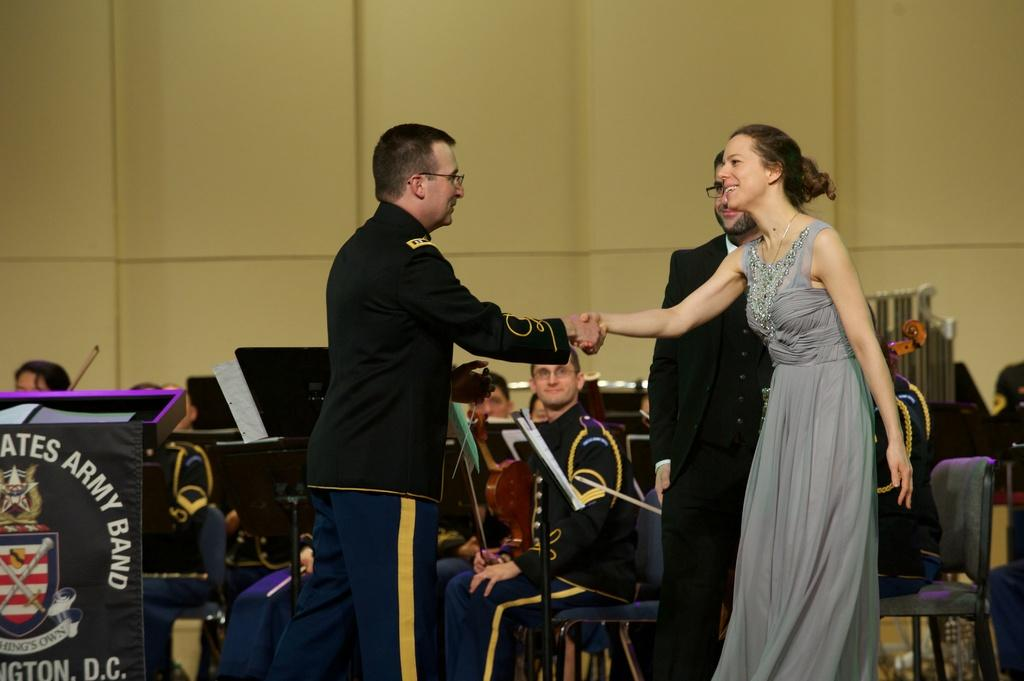What are the two people in the image doing? Two people are shaking hands in the image. What can be seen in the background of the image? There are people sitting on chairs in the background. What objects related to learning or knowledge are visible in the image? There are books visible in the image. What type of furniture is present in the image? There is a stand and a podium in the image. What is the color of the wall in the image? The wall is in cream color. How many sacks are being carried by the people in the image? There are no sacks visible in the image; the people are shaking hands. Are the people in the image sleeping or resting? No, the people in the image are not sleeping or resting; they are shaking hands and sitting on chairs. 